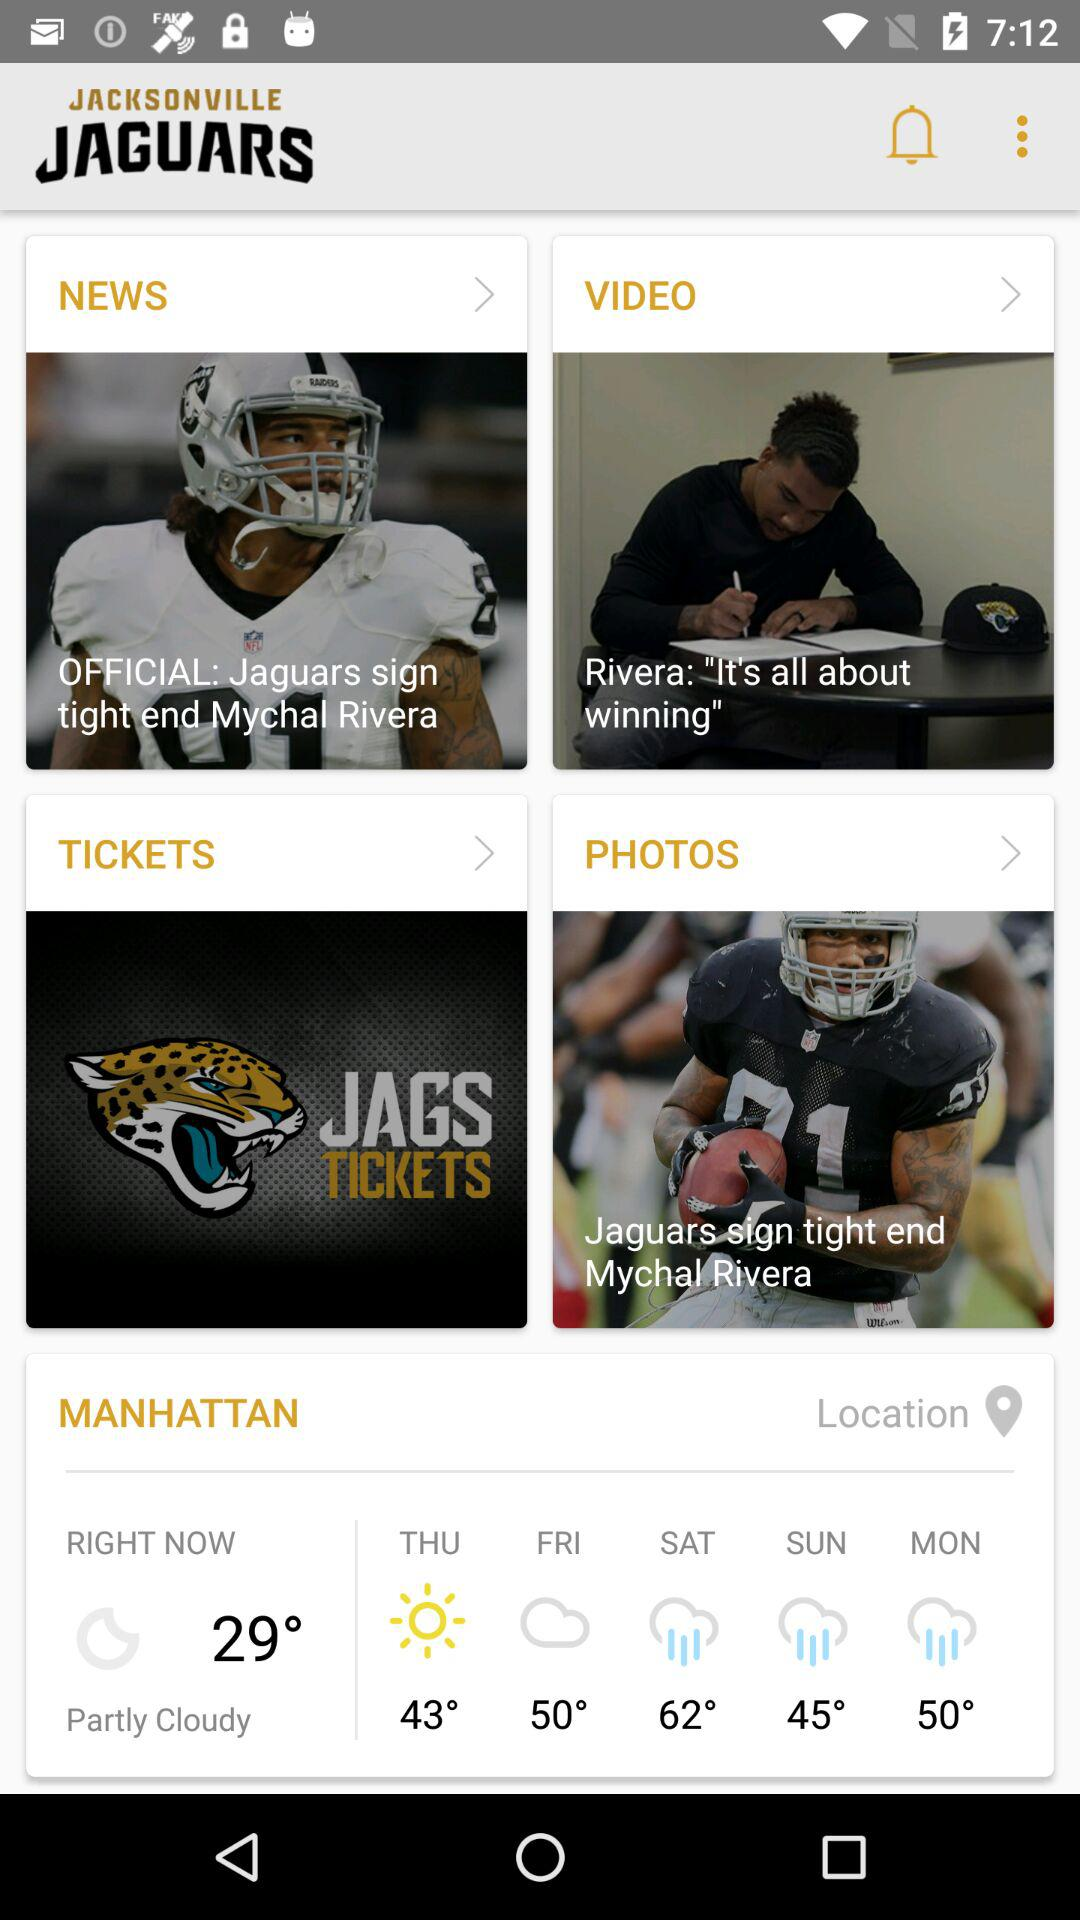Which day have minimum temperature?
When the provided information is insufficient, respond with <no answer>. <no answer> 